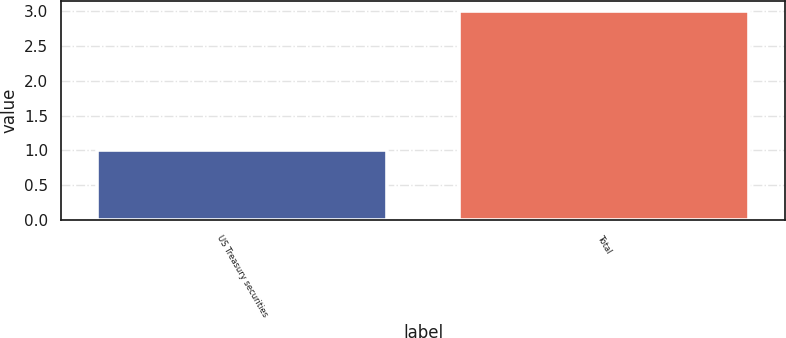<chart> <loc_0><loc_0><loc_500><loc_500><bar_chart><fcel>US Treasury securities<fcel>Total<nl><fcel>1<fcel>3<nl></chart> 